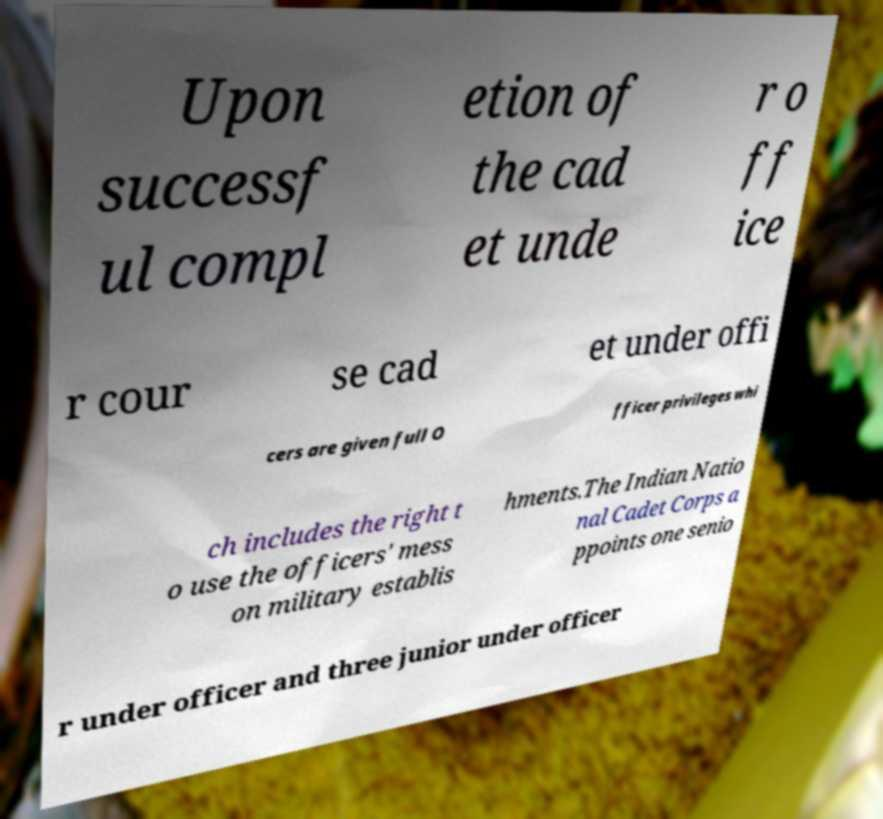There's text embedded in this image that I need extracted. Can you transcribe it verbatim? Upon successf ul compl etion of the cad et unde r o ff ice r cour se cad et under offi cers are given full O fficer privileges whi ch includes the right t o use the officers' mess on military establis hments.The Indian Natio nal Cadet Corps a ppoints one senio r under officer and three junior under officer 